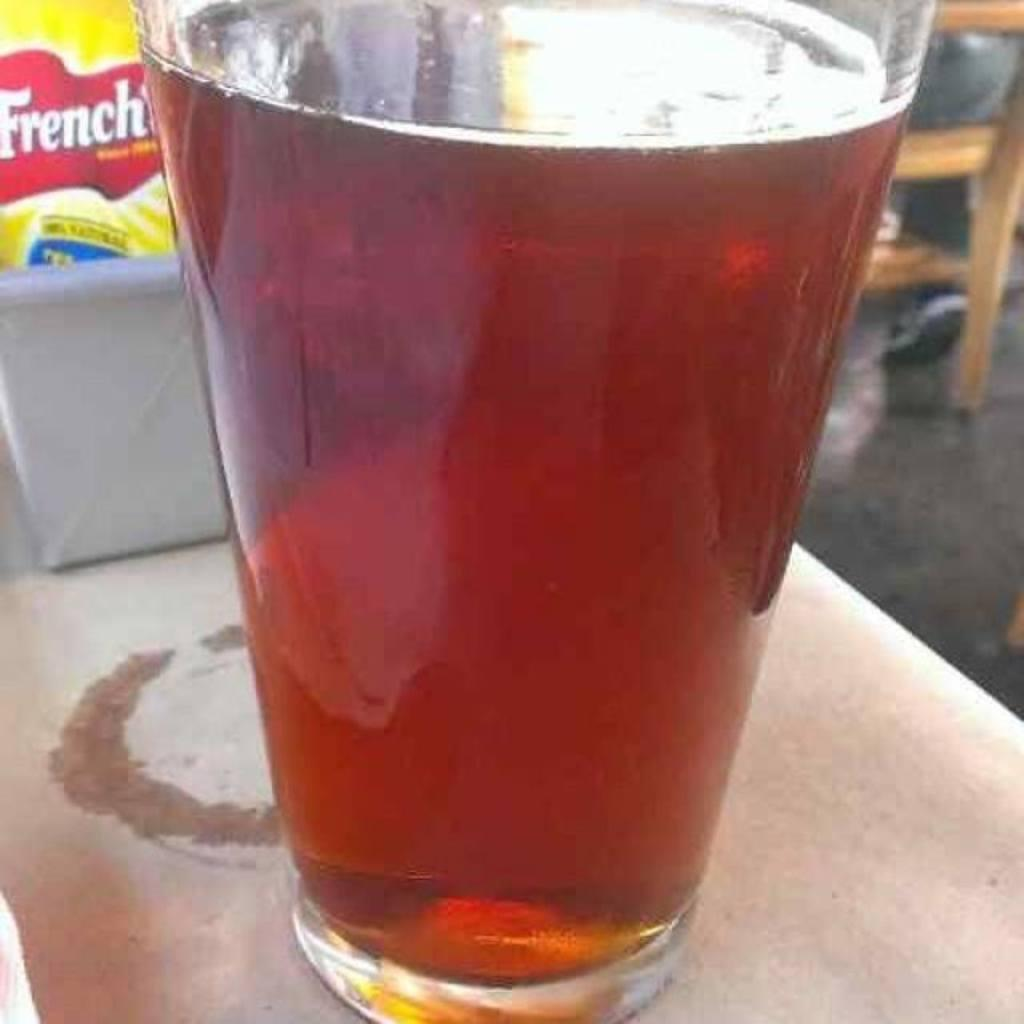What is in the glass that is visible in the image? There is a glass of drink in the image. What other items can be seen in the image besides the glass? There is a packet in a box in the image. Where are the glass and the box located in the image? The glass and the box are on a table in the image. What type of furniture is present in the image? There is a chair in the image. What type of poison is present in the glass in the image? There is no poison present in the glass in the image; it contains a drink. How many dolls can be seen interacting with the chair in the image? There are no dolls present in the image. 